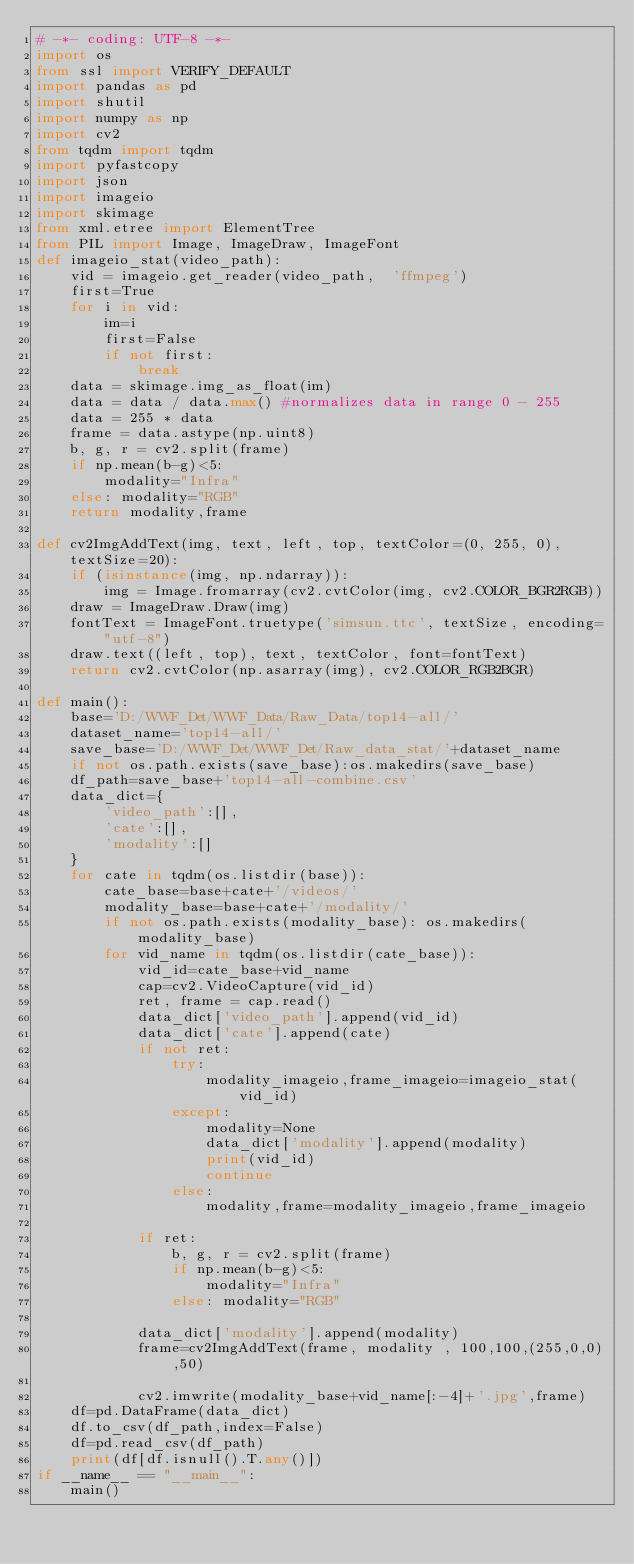<code> <loc_0><loc_0><loc_500><loc_500><_Python_># -*- coding: UTF-8 -*-
import os
from ssl import VERIFY_DEFAULT
import pandas as pd
import shutil
import numpy as np
import cv2
from tqdm import tqdm
import pyfastcopy
import json
import imageio
import skimage
from xml.etree import ElementTree
from PIL import Image, ImageDraw, ImageFont
def imageio_stat(video_path):
    vid = imageio.get_reader(video_path,  'ffmpeg')
    first=True
    for i in vid:
        im=i
        first=False
        if not first:
            break
    data = skimage.img_as_float(im)
    data = data / data.max() #normalizes data in range 0 - 255
    data = 255 * data
    frame = data.astype(np.uint8)
    b, g, r = cv2.split(frame)
    if np.mean(b-g)<5:
        modality="Infra"
    else: modality="RGB"
    return modality,frame

def cv2ImgAddText(img, text, left, top, textColor=(0, 255, 0), textSize=20):
    if (isinstance(img, np.ndarray)):
        img = Image.fromarray(cv2.cvtColor(img, cv2.COLOR_BGR2RGB))
    draw = ImageDraw.Draw(img)
    fontText = ImageFont.truetype('simsun.ttc', textSize, encoding="utf-8")
    draw.text((left, top), text, textColor, font=fontText)
    return cv2.cvtColor(np.asarray(img), cv2.COLOR_RGB2BGR)

def main():
    base='D:/WWF_Det/WWF_Data/Raw_Data/top14-all/'
    dataset_name='top14-all/'
    save_base='D:/WWF_Det/WWF_Det/Raw_data_stat/'+dataset_name
    if not os.path.exists(save_base):os.makedirs(save_base)
    df_path=save_base+'top14-all-combine.csv'
    data_dict={
        'video_path':[],
        'cate':[],
        'modality':[]
    }
    for cate in tqdm(os.listdir(base)):
        cate_base=base+cate+'/videos/'
        modality_base=base+cate+'/modality/'
        if not os.path.exists(modality_base): os.makedirs(modality_base)
        for vid_name in tqdm(os.listdir(cate_base)):
            vid_id=cate_base+vid_name
            cap=cv2.VideoCapture(vid_id)
            ret, frame = cap.read()
            data_dict['video_path'].append(vid_id)
            data_dict['cate'].append(cate)
            if not ret: 
                try:
                    modality_imageio,frame_imageio=imageio_stat(vid_id)
                except:
                    modality=None
                    data_dict['modality'].append(modality)
                    print(vid_id)
                    continue
                else:
                    modality,frame=modality_imageio,frame_imageio
                    
            if ret:
                b, g, r = cv2.split(frame)
                if np.mean(b-g)<5:
                    modality="Infra"
                else: modality="RGB"
        
            data_dict['modality'].append(modality)
            frame=cv2ImgAddText(frame, modality , 100,100,(255,0,0),50)

            cv2.imwrite(modality_base+vid_name[:-4]+'.jpg',frame)
    df=pd.DataFrame(data_dict)
    df.to_csv(df_path,index=False)
    df=pd.read_csv(df_path)
    print(df[df.isnull().T.any()])
if __name__ == "__main__":
    main()</code> 